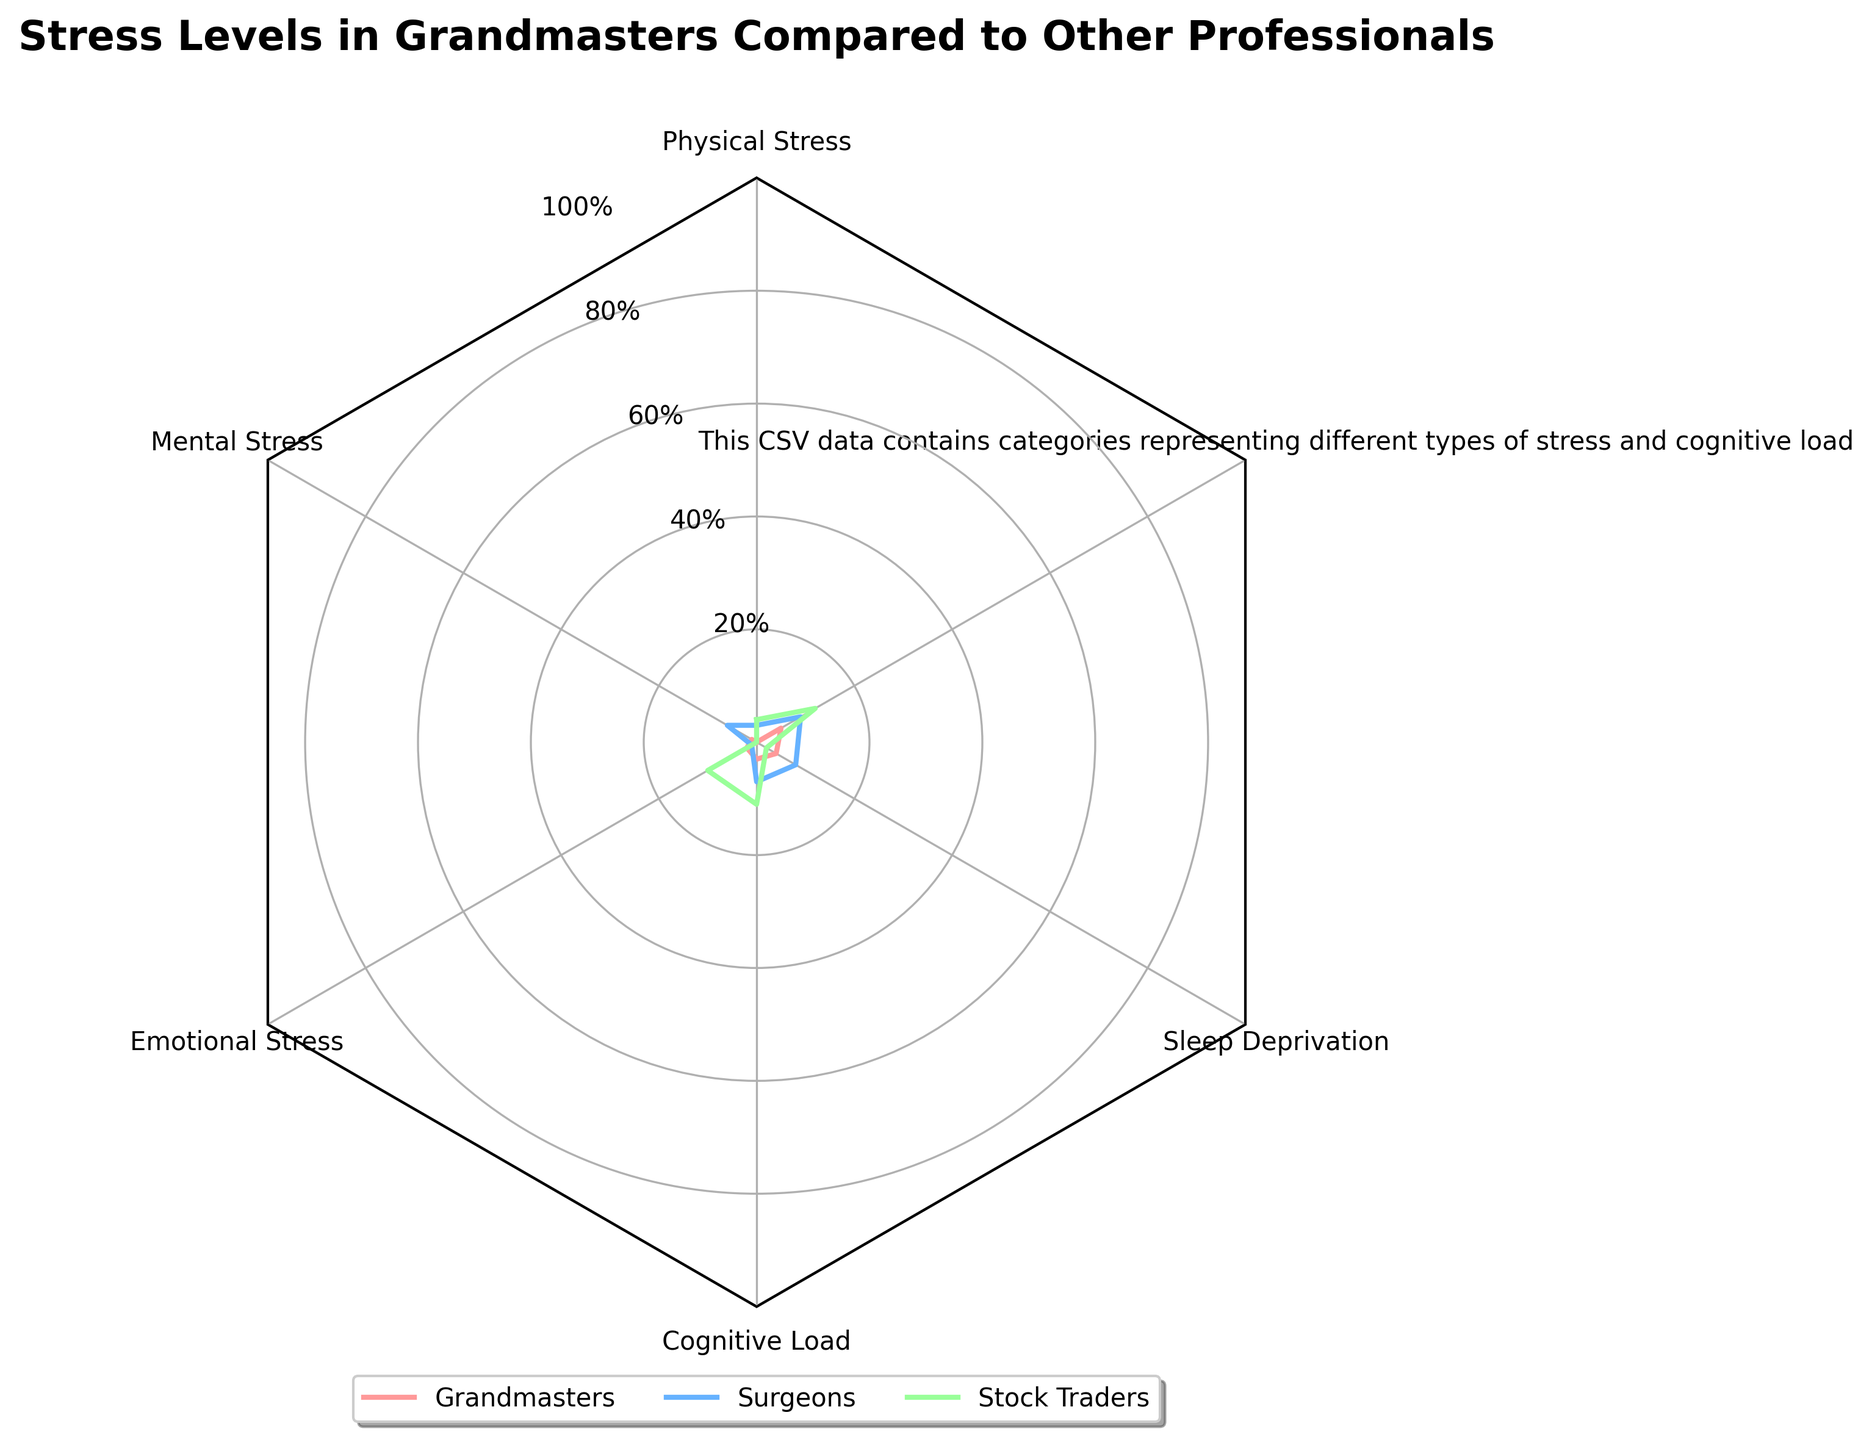Q: What is the title of the radar chart? The title is located at the top of the figure. It reads "Stress Levels in Grandmasters Compared to Other Professionals".
Answer: Stress Levels in Grandmasters Compared to Other Professionals Q: Which group has the highest mental stress? By locating the 'Mental Stress' category and comparing the values for each group, we see that Surgeons have the highest mental stress level (95).
Answer: Surgeons Q: What are the colors representing each group in the radar chart? The legend at the bottom of the chart shows colors associated with each group: Grandmasters are represented by red, Surgeons by blue, and Stock Traders by green.
Answer: Grandmasters - Red, Surgeons - Blue, Stock Traders - Green Q: What is the average value of cognitive load across all the groups shown? First, find the cognitive load values for each group: Grandmasters (90), Surgeons (88), and Stock Traders (82). Average these values: (90+88+82)/3 = 260/3 = ~86.67.
Answer: ~86.67 Q: Are Grandmasters generally more or less stressed than Stock Traders across the categories? Compare the values category by category: Grandmasters generally have higher values in Physical Stress (80 vs 75), Mental Stress (85 vs 80), Emotional Stress (70 vs 78), Cognitive Load (90 vs 82), and Sleep Deprivation (75 vs 70). Grandmasters are more stressed in most categories.
Answer: More stressed Q: Which category shows the most considerable difference between Grandmasters and Surgeons? Calculate the differences per category: Physical Stress (10), Mental Stress (10), Emotional Stress (15), Cognitive Load (2), Sleep Deprivation (17). The highest difference is in Sleep Deprivation (17).
Answer: Sleep Deprivation Q: How does the cognitive load of Grandmasters compare to that of Software Engineers? For the category 'Cognitive Load', compare values: Grandmasters (90) and Software Engineers (65). Grandmasters have significantly higher cognitive load.
Answer: Higher Q: What is the range of sleep deprivation levels for the groups shown? Identify the highest and lowest sleep deprivation values: highest is Surgeons (92), and lowest is Software Engineers (45). The range is 92-45 = 47.
Answer: 47 Q: Which group, on average, experiences the highest overall stress? Sum all stress categories for each group and find the average: Grandmasters (80+85+70+90+75=400), Surgeons (90+95+85+88+92=450), Stock Traders (75+80+78+82+70=385). Surgeons have the highest total, so their average is the highest.
Answer: Surgeons 